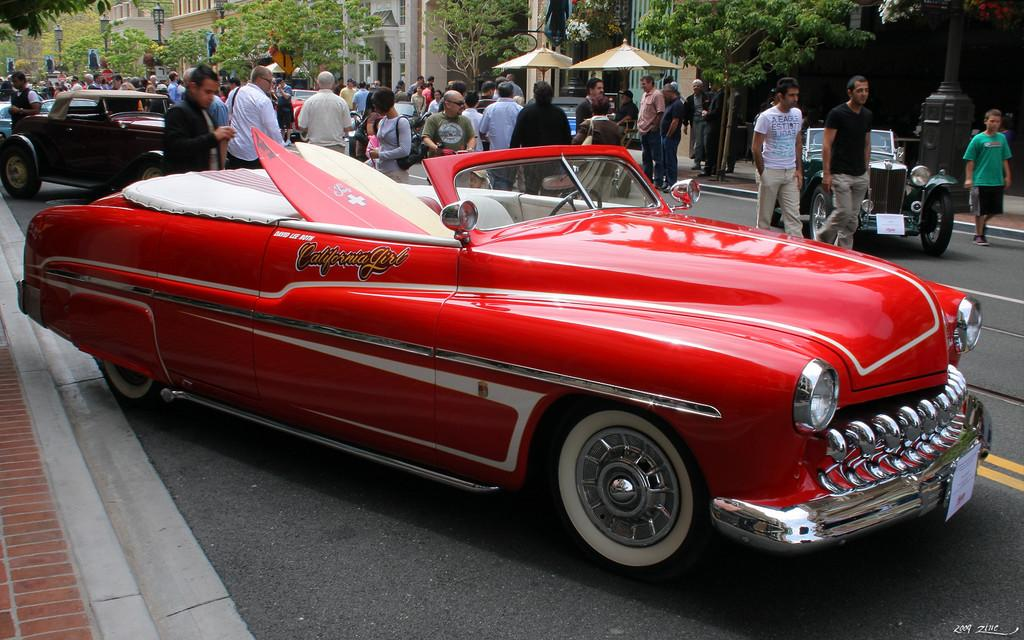What can be seen on the road in the image? There are cars on the road in the image. What are the people near the cars doing? People are standing beside the cars. What can be seen in the background of the image? There are trees, buildings, and street lights in the background of the image. What type of lace can be seen hanging from the trees in the image? There is no lace present in the image; it features cars on the road, people standing beside the cars, and a background with trees, buildings, and street lights. How many oranges are visible on the cars in the image? There are no oranges visible on the cars in the image; it only shows cars, people, and the background elements. 